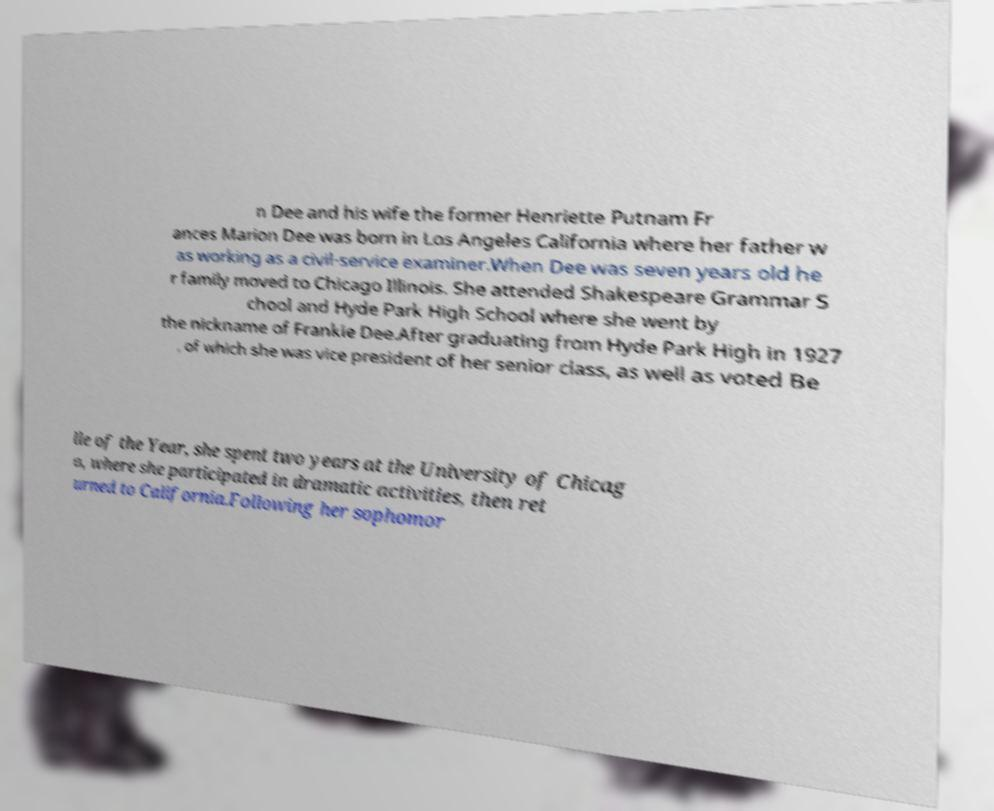There's text embedded in this image that I need extracted. Can you transcribe it verbatim? n Dee and his wife the former Henriette Putnam Fr ances Marion Dee was born in Los Angeles California where her father w as working as a civil-service examiner.When Dee was seven years old he r family moved to Chicago Illinois. She attended Shakespeare Grammar S chool and Hyde Park High School where she went by the nickname of Frankie Dee.After graduating from Hyde Park High in 1927 , of which she was vice president of her senior class, as well as voted Be lle of the Year, she spent two years at the University of Chicag o, where she participated in dramatic activities, then ret urned to California.Following her sophomor 